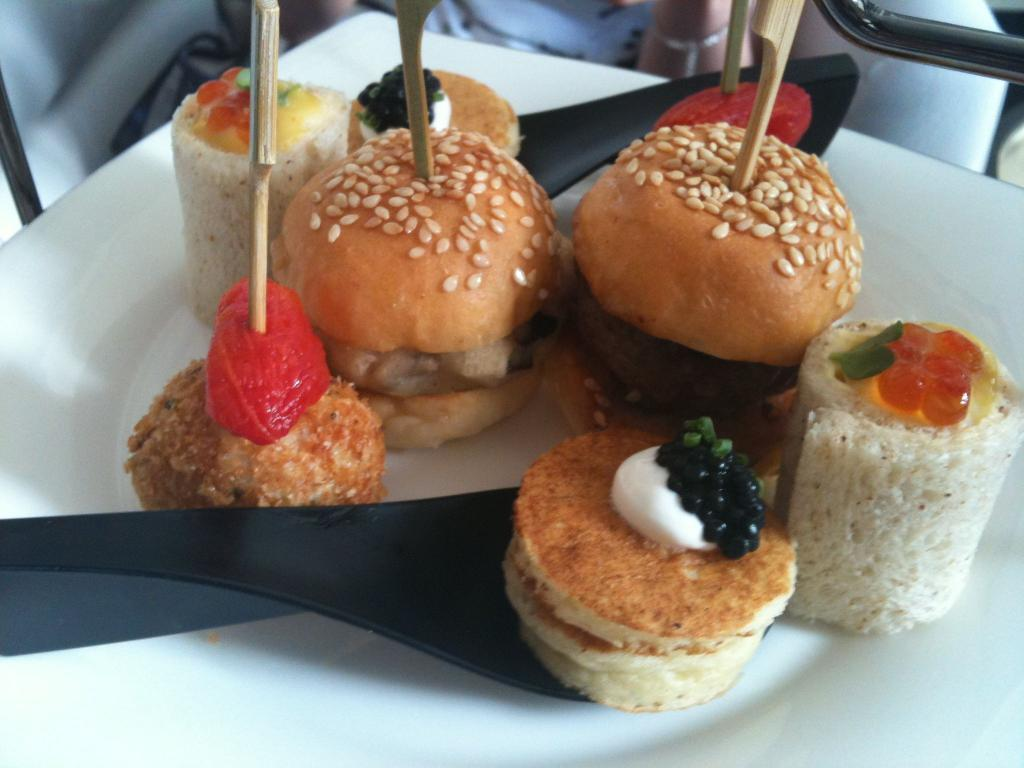What is on the plate in the image? There is food on the plate in the image. Can you describe the colors of the food? The food has brown, red, white, and black colors. What color is the plate? The plate is white. What utensil is present in the image? There is a black-colored spoon in the image. What verse is recited by the coach in the image? There is no coach or verse present in the image. 